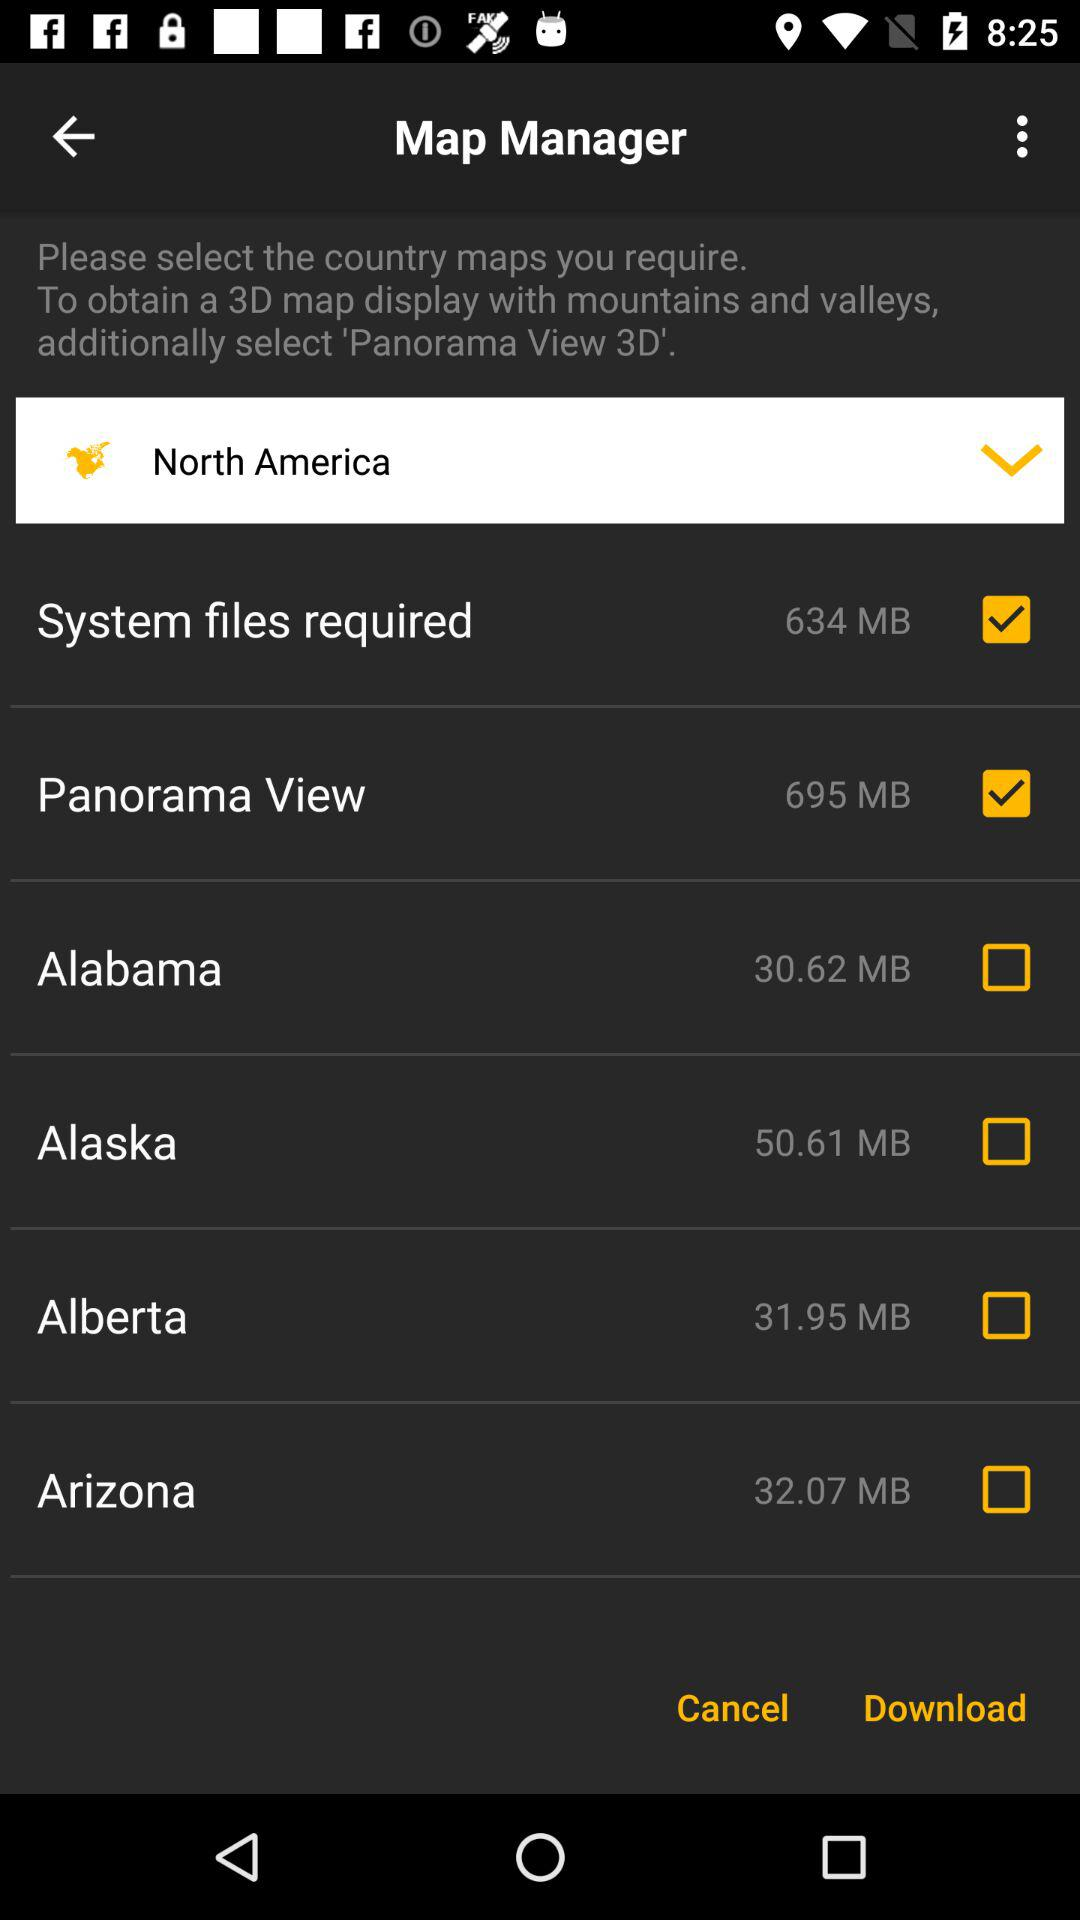What is the status of the "System files required"? The status is "on". 